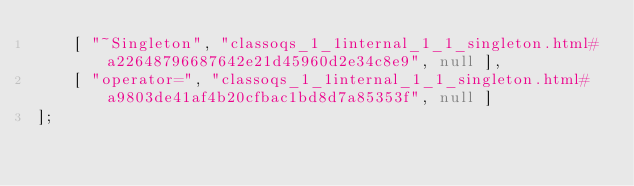Convert code to text. <code><loc_0><loc_0><loc_500><loc_500><_JavaScript_>    [ "~Singleton", "classoqs_1_1internal_1_1_singleton.html#a22648796687642e21d45960d2e34c8e9", null ],
    [ "operator=", "classoqs_1_1internal_1_1_singleton.html#a9803de41af4b20cfbac1bd8d7a85353f", null ]
];</code> 